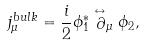<formula> <loc_0><loc_0><loc_500><loc_500>j ^ { b u l k } _ { \mu } = \frac { i } { 2 } \phi _ { 1 } ^ { * } \stackrel { \leftrightarrow } \partial _ { \mu } \phi _ { 2 } ,</formula> 